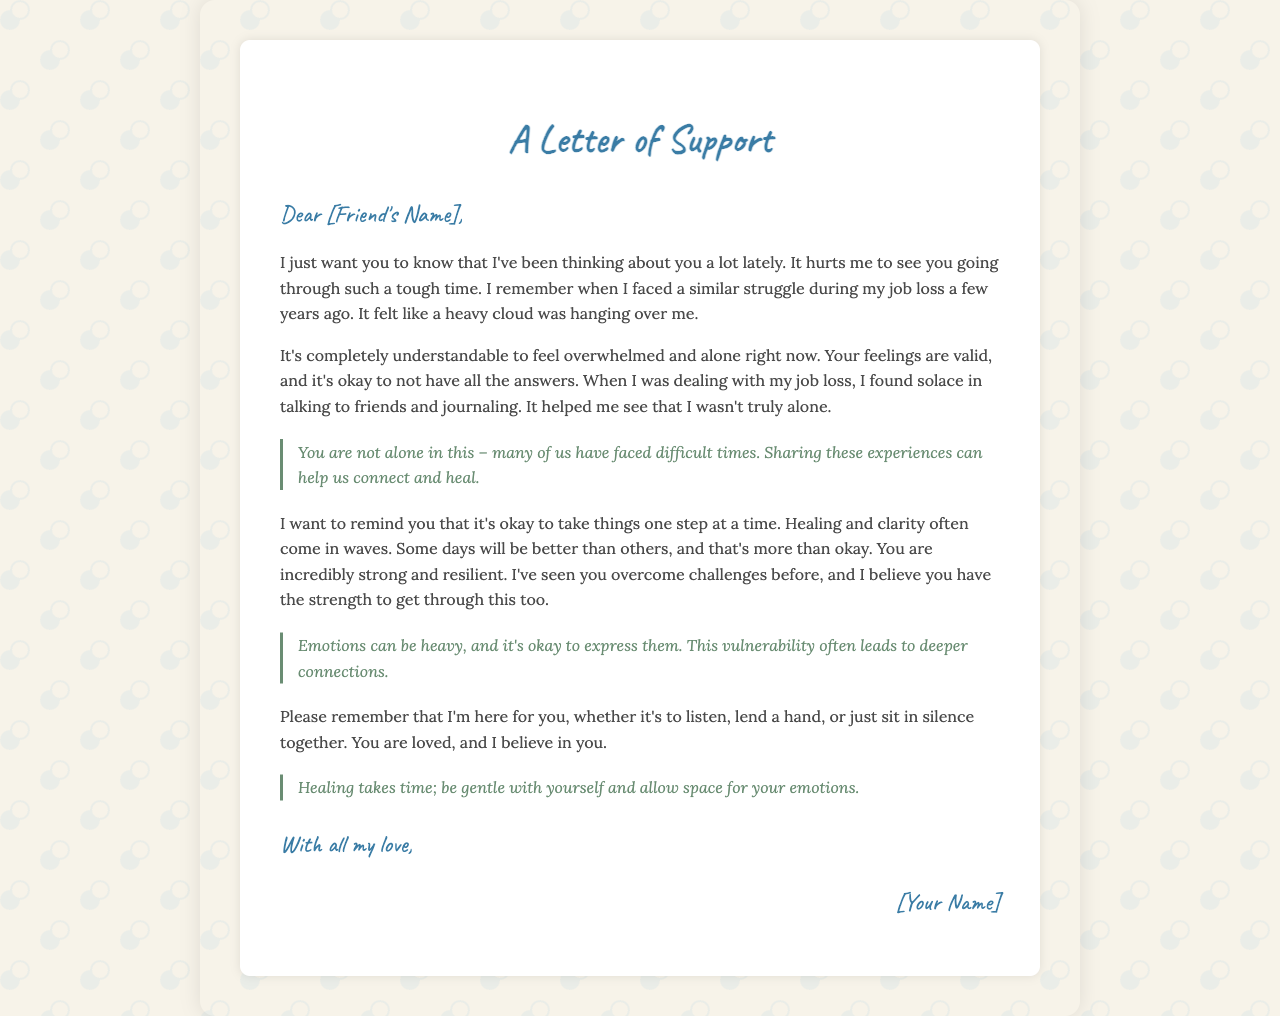What is the title of the letter? The title of the letter is prominently displayed at the top of the document.
Answer: A Letter of Support Who is the letter addressed to? The greeting section specifies the recipient of the letter.
Answer: [Friend's Name] What personal experience does the writer mention? The writer shares a personal struggle during a specific life event.
Answer: job loss What key message emphasizes shared experiences? There is a key message that highlights shared experiences and connections.
Answer: You are not alone in this – many of us have faced difficult times. Sharing these experiences can help us connect and heal What emotion does the writer say it's okay to express? The writer acknowledges that certain emotions can be difficult to handle.
Answer: Emotions can be heavy How does the writer describe the process of healing? The letter explains the nature of healing through a specific phrase.
Answer: Healing takes time; be gentle with yourself and allow space for your emotions What is the closing phrase of the letter? The closing statement summarizes the writer's feelings towards the recipient.
Answer: With all my love What message does the writer convey about strength? The writer reinforces the strength of the recipient in overcoming challenges.
Answer: You are incredibly strong and resilient 